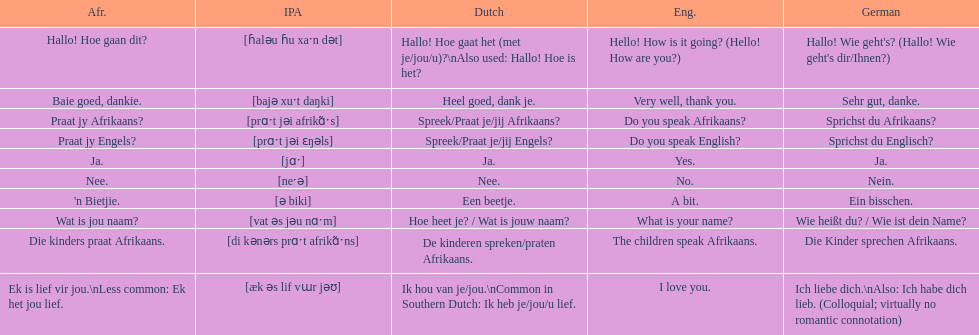How do you say 'do you speak afrikaans?' in afrikaans? Praat jy Afrikaans?. 